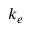<formula> <loc_0><loc_0><loc_500><loc_500>k _ { e }</formula> 